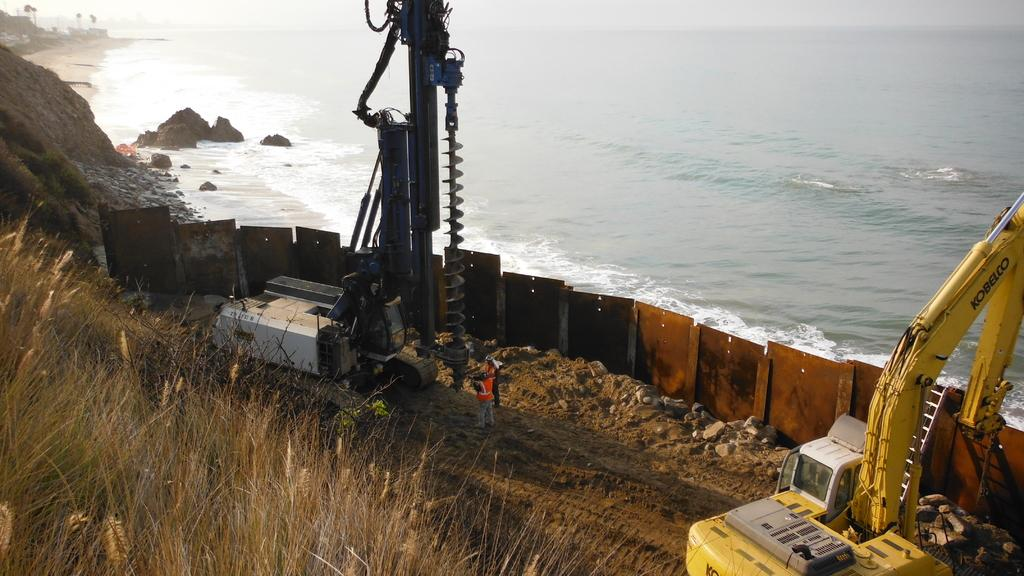What type of machinery is present in the image? There is a crane in the image. What else can be seen in the image besides the crane? There is a vehicle, people, a fence, water, grass, rocks, and the sky visible in the image. Can you describe the terrain in the image? The image shows a combination of grass, rocks, and water. What is the background of the image? The sky is visible in the background of the image. What type of division is being carried out in the image? There is no division being carried out in the image; it is a scene with a crane, vehicle, people, fence, water, grass, rocks, and the sky. What is the weather like in the image? The provided facts do not mention the weather, so it cannot be determined from the image. 